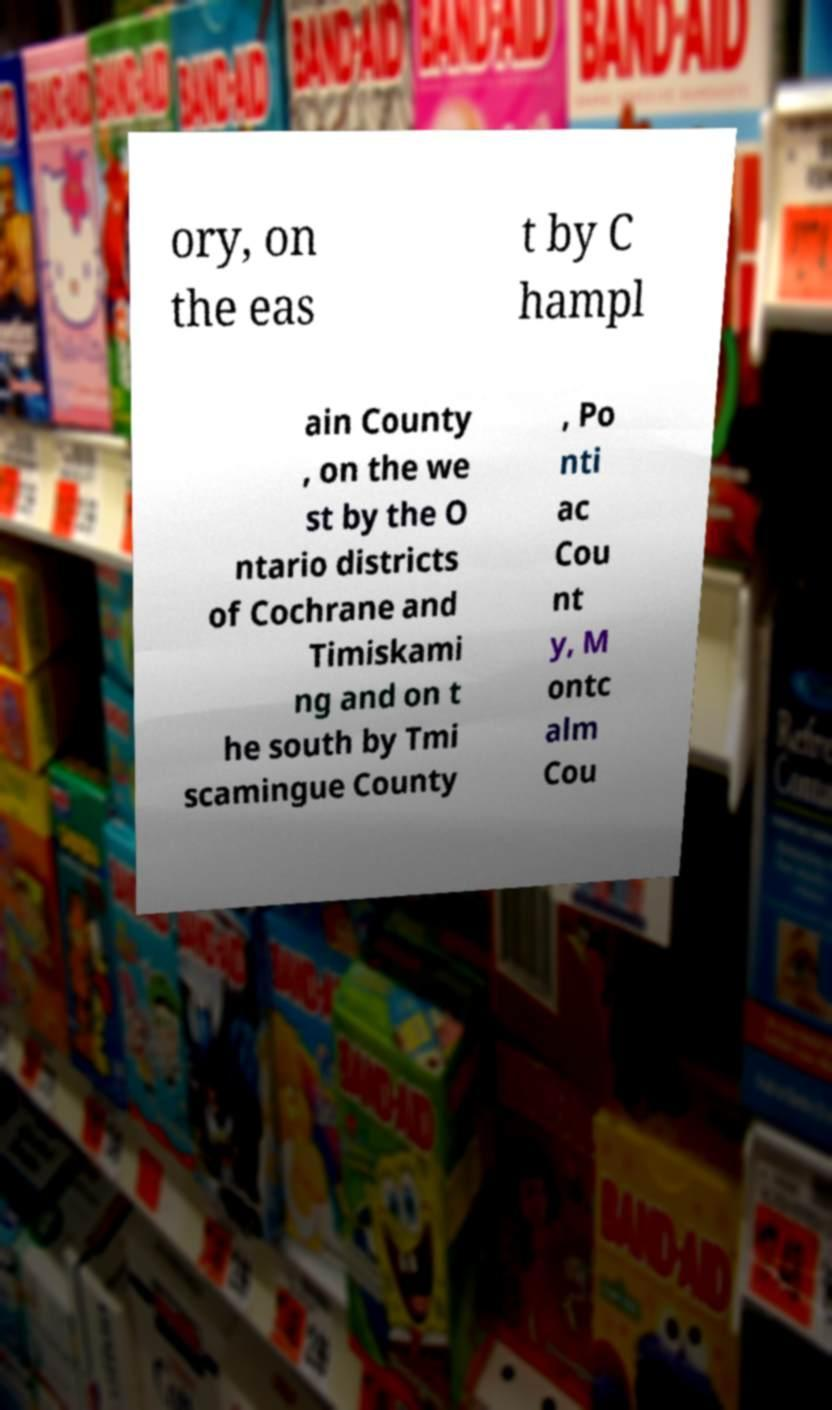Please read and relay the text visible in this image. What does it say? ory, on the eas t by C hampl ain County , on the we st by the O ntario districts of Cochrane and Timiskami ng and on t he south by Tmi scamingue County , Po nti ac Cou nt y, M ontc alm Cou 